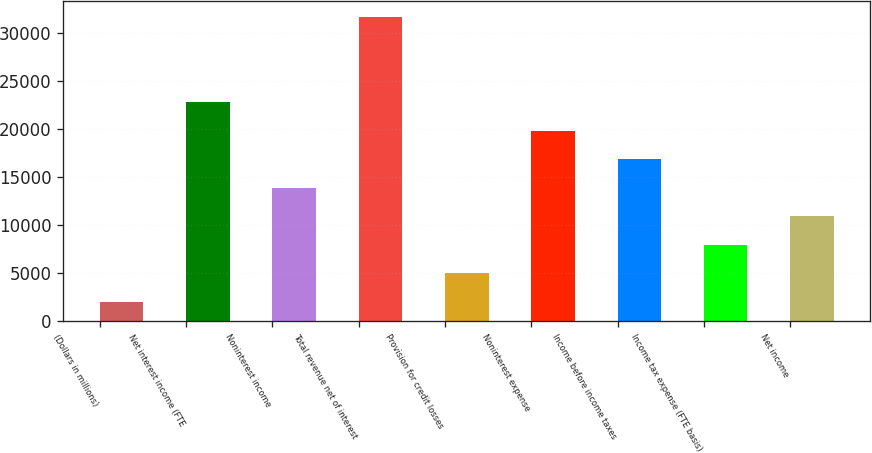Convert chart to OTSL. <chart><loc_0><loc_0><loc_500><loc_500><bar_chart><fcel>(Dollars in millions)<fcel>Net interest income (FTE<fcel>Noninterest income<fcel>Total revenue net of interest<fcel>Provision for credit losses<fcel>Noninterest expense<fcel>Income before income taxes<fcel>Income tax expense (FTE basis)<fcel>Net income<nl><fcel>2016<fcel>22816.5<fcel>13902<fcel>31731<fcel>4987.5<fcel>19845<fcel>16873.5<fcel>7959<fcel>10930.5<nl></chart> 